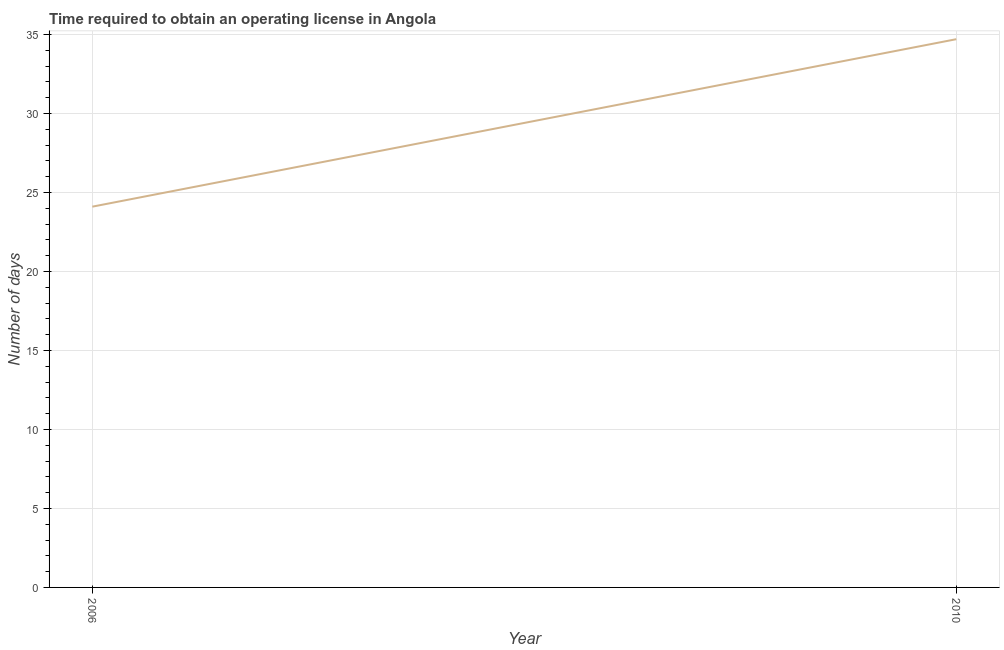What is the number of days to obtain operating license in 2010?
Provide a succinct answer. 34.7. Across all years, what is the maximum number of days to obtain operating license?
Provide a short and direct response. 34.7. Across all years, what is the minimum number of days to obtain operating license?
Keep it short and to the point. 24.1. In which year was the number of days to obtain operating license maximum?
Give a very brief answer. 2010. What is the sum of the number of days to obtain operating license?
Your answer should be compact. 58.8. What is the difference between the number of days to obtain operating license in 2006 and 2010?
Give a very brief answer. -10.6. What is the average number of days to obtain operating license per year?
Your response must be concise. 29.4. What is the median number of days to obtain operating license?
Keep it short and to the point. 29.4. In how many years, is the number of days to obtain operating license greater than 32 days?
Your answer should be very brief. 1. Do a majority of the years between 2010 and 2006 (inclusive) have number of days to obtain operating license greater than 2 days?
Ensure brevity in your answer.  No. What is the ratio of the number of days to obtain operating license in 2006 to that in 2010?
Your answer should be very brief. 0.69. Does the graph contain any zero values?
Provide a short and direct response. No. What is the title of the graph?
Provide a succinct answer. Time required to obtain an operating license in Angola. What is the label or title of the X-axis?
Give a very brief answer. Year. What is the label or title of the Y-axis?
Provide a succinct answer. Number of days. What is the Number of days in 2006?
Your answer should be very brief. 24.1. What is the Number of days in 2010?
Your answer should be compact. 34.7. What is the ratio of the Number of days in 2006 to that in 2010?
Ensure brevity in your answer.  0.69. 